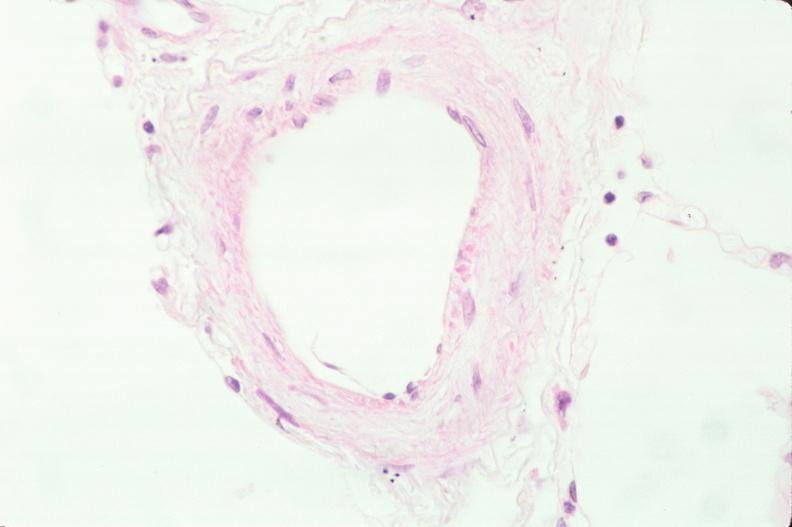where is this?
Answer the question using a single word or phrase. Lung 